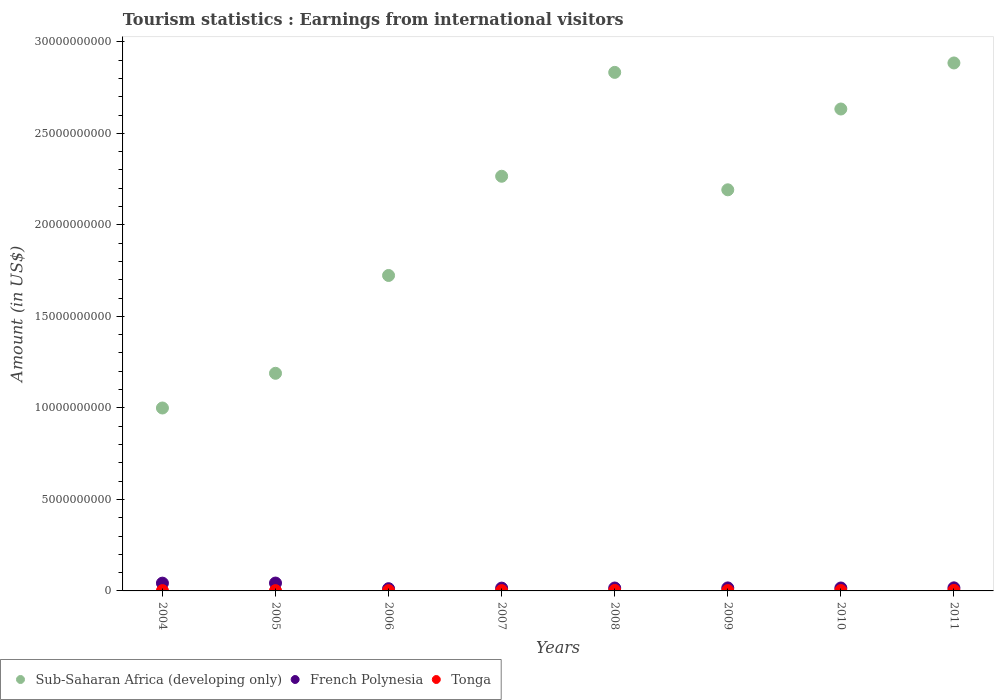How many different coloured dotlines are there?
Your answer should be compact. 3. Is the number of dotlines equal to the number of legend labels?
Give a very brief answer. Yes. What is the earnings from international visitors in Sub-Saharan Africa (developing only) in 2005?
Provide a succinct answer. 1.19e+1. Across all years, what is the maximum earnings from international visitors in Sub-Saharan Africa (developing only)?
Provide a succinct answer. 2.88e+1. Across all years, what is the minimum earnings from international visitors in French Polynesia?
Keep it short and to the point. 1.22e+08. What is the total earnings from international visitors in French Polynesia in the graph?
Your answer should be very brief. 1.78e+09. What is the difference between the earnings from international visitors in Tonga in 2005 and that in 2011?
Your answer should be compact. -1.18e+07. What is the difference between the earnings from international visitors in French Polynesia in 2004 and the earnings from international visitors in Tonga in 2010?
Your answer should be very brief. 4.05e+08. What is the average earnings from international visitors in French Polynesia per year?
Offer a terse response. 2.23e+08. In the year 2006, what is the difference between the earnings from international visitors in Sub-Saharan Africa (developing only) and earnings from international visitors in Tonga?
Your answer should be compact. 1.72e+1. In how many years, is the earnings from international visitors in French Polynesia greater than 25000000000 US$?
Ensure brevity in your answer.  0. What is the ratio of the earnings from international visitors in French Polynesia in 2006 to that in 2008?
Offer a terse response. 0.77. Is the earnings from international visitors in French Polynesia in 2008 less than that in 2009?
Your answer should be very brief. Yes. What is the difference between the highest and the second highest earnings from international visitors in Sub-Saharan Africa (developing only)?
Ensure brevity in your answer.  5.15e+08. What is the difference between the highest and the lowest earnings from international visitors in French Polynesia?
Your response must be concise. 3.08e+08. Is the sum of the earnings from international visitors in Tonga in 2007 and 2009 greater than the maximum earnings from international visitors in French Polynesia across all years?
Your answer should be very brief. No. Does the earnings from international visitors in Tonga monotonically increase over the years?
Provide a succinct answer. No. Is the earnings from international visitors in French Polynesia strictly less than the earnings from international visitors in Sub-Saharan Africa (developing only) over the years?
Give a very brief answer. Yes. How many dotlines are there?
Make the answer very short. 3. How many years are there in the graph?
Give a very brief answer. 8. Are the values on the major ticks of Y-axis written in scientific E-notation?
Offer a very short reply. No. Does the graph contain any zero values?
Your answer should be compact. No. Where does the legend appear in the graph?
Keep it short and to the point. Bottom left. How are the legend labels stacked?
Ensure brevity in your answer.  Horizontal. What is the title of the graph?
Keep it short and to the point. Tourism statistics : Earnings from international visitors. Does "Syrian Arab Republic" appear as one of the legend labels in the graph?
Offer a very short reply. No. What is the label or title of the X-axis?
Your answer should be very brief. Years. What is the label or title of the Y-axis?
Ensure brevity in your answer.  Amount (in US$). What is the Amount (in US$) of Sub-Saharan Africa (developing only) in 2004?
Give a very brief answer. 9.99e+09. What is the Amount (in US$) in French Polynesia in 2004?
Offer a very short reply. 4.25e+08. What is the Amount (in US$) in Tonga in 2004?
Give a very brief answer. 1.62e+07. What is the Amount (in US$) in Sub-Saharan Africa (developing only) in 2005?
Provide a succinct answer. 1.19e+1. What is the Amount (in US$) of French Polynesia in 2005?
Provide a short and direct response. 4.30e+08. What is the Amount (in US$) of Tonga in 2005?
Your answer should be compact. 1.60e+07. What is the Amount (in US$) in Sub-Saharan Africa (developing only) in 2006?
Provide a succinct answer. 1.72e+1. What is the Amount (in US$) of French Polynesia in 2006?
Provide a succinct answer. 1.22e+08. What is the Amount (in US$) of Tonga in 2006?
Make the answer very short. 1.50e+07. What is the Amount (in US$) of Sub-Saharan Africa (developing only) in 2007?
Your answer should be very brief. 2.27e+1. What is the Amount (in US$) in French Polynesia in 2007?
Your response must be concise. 1.53e+08. What is the Amount (in US$) in Tonga in 2007?
Your response must be concise. 1.73e+07. What is the Amount (in US$) of Sub-Saharan Africa (developing only) in 2008?
Make the answer very short. 2.83e+1. What is the Amount (in US$) of French Polynesia in 2008?
Ensure brevity in your answer.  1.59e+08. What is the Amount (in US$) in Tonga in 2008?
Your answer should be very brief. 2.51e+07. What is the Amount (in US$) of Sub-Saharan Africa (developing only) in 2009?
Your response must be concise. 2.19e+1. What is the Amount (in US$) in French Polynesia in 2009?
Provide a succinct answer. 1.64e+08. What is the Amount (in US$) of Tonga in 2009?
Your answer should be compact. 1.91e+07. What is the Amount (in US$) in Sub-Saharan Africa (developing only) in 2010?
Keep it short and to the point. 2.63e+1. What is the Amount (in US$) in French Polynesia in 2010?
Offer a very short reply. 1.60e+08. What is the Amount (in US$) of Tonga in 2010?
Keep it short and to the point. 2.04e+07. What is the Amount (in US$) in Sub-Saharan Africa (developing only) in 2011?
Offer a very short reply. 2.88e+1. What is the Amount (in US$) in French Polynesia in 2011?
Keep it short and to the point. 1.68e+08. What is the Amount (in US$) of Tonga in 2011?
Give a very brief answer. 2.78e+07. Across all years, what is the maximum Amount (in US$) in Sub-Saharan Africa (developing only)?
Your answer should be compact. 2.88e+1. Across all years, what is the maximum Amount (in US$) in French Polynesia?
Provide a short and direct response. 4.30e+08. Across all years, what is the maximum Amount (in US$) in Tonga?
Provide a succinct answer. 2.78e+07. Across all years, what is the minimum Amount (in US$) in Sub-Saharan Africa (developing only)?
Your response must be concise. 9.99e+09. Across all years, what is the minimum Amount (in US$) of French Polynesia?
Give a very brief answer. 1.22e+08. Across all years, what is the minimum Amount (in US$) in Tonga?
Your answer should be compact. 1.50e+07. What is the total Amount (in US$) of Sub-Saharan Africa (developing only) in the graph?
Offer a terse response. 1.67e+11. What is the total Amount (in US$) in French Polynesia in the graph?
Your answer should be very brief. 1.78e+09. What is the total Amount (in US$) of Tonga in the graph?
Your answer should be compact. 1.57e+08. What is the difference between the Amount (in US$) of Sub-Saharan Africa (developing only) in 2004 and that in 2005?
Keep it short and to the point. -1.90e+09. What is the difference between the Amount (in US$) in French Polynesia in 2004 and that in 2005?
Your response must be concise. -5.00e+06. What is the difference between the Amount (in US$) of Tonga in 2004 and that in 2005?
Make the answer very short. 2.00e+05. What is the difference between the Amount (in US$) of Sub-Saharan Africa (developing only) in 2004 and that in 2006?
Offer a terse response. -7.24e+09. What is the difference between the Amount (in US$) in French Polynesia in 2004 and that in 2006?
Make the answer very short. 3.03e+08. What is the difference between the Amount (in US$) of Tonga in 2004 and that in 2006?
Ensure brevity in your answer.  1.20e+06. What is the difference between the Amount (in US$) of Sub-Saharan Africa (developing only) in 2004 and that in 2007?
Provide a succinct answer. -1.27e+1. What is the difference between the Amount (in US$) in French Polynesia in 2004 and that in 2007?
Offer a very short reply. 2.72e+08. What is the difference between the Amount (in US$) of Tonga in 2004 and that in 2007?
Your answer should be very brief. -1.10e+06. What is the difference between the Amount (in US$) in Sub-Saharan Africa (developing only) in 2004 and that in 2008?
Ensure brevity in your answer.  -1.83e+1. What is the difference between the Amount (in US$) of French Polynesia in 2004 and that in 2008?
Ensure brevity in your answer.  2.66e+08. What is the difference between the Amount (in US$) of Tonga in 2004 and that in 2008?
Offer a very short reply. -8.90e+06. What is the difference between the Amount (in US$) in Sub-Saharan Africa (developing only) in 2004 and that in 2009?
Keep it short and to the point. -1.19e+1. What is the difference between the Amount (in US$) in French Polynesia in 2004 and that in 2009?
Provide a succinct answer. 2.61e+08. What is the difference between the Amount (in US$) of Tonga in 2004 and that in 2009?
Offer a very short reply. -2.90e+06. What is the difference between the Amount (in US$) of Sub-Saharan Africa (developing only) in 2004 and that in 2010?
Your response must be concise. -1.63e+1. What is the difference between the Amount (in US$) of French Polynesia in 2004 and that in 2010?
Offer a terse response. 2.65e+08. What is the difference between the Amount (in US$) of Tonga in 2004 and that in 2010?
Your answer should be compact. -4.20e+06. What is the difference between the Amount (in US$) in Sub-Saharan Africa (developing only) in 2004 and that in 2011?
Ensure brevity in your answer.  -1.89e+1. What is the difference between the Amount (in US$) of French Polynesia in 2004 and that in 2011?
Provide a succinct answer. 2.57e+08. What is the difference between the Amount (in US$) in Tonga in 2004 and that in 2011?
Keep it short and to the point. -1.16e+07. What is the difference between the Amount (in US$) in Sub-Saharan Africa (developing only) in 2005 and that in 2006?
Your response must be concise. -5.34e+09. What is the difference between the Amount (in US$) in French Polynesia in 2005 and that in 2006?
Offer a very short reply. 3.08e+08. What is the difference between the Amount (in US$) of Sub-Saharan Africa (developing only) in 2005 and that in 2007?
Give a very brief answer. -1.08e+1. What is the difference between the Amount (in US$) of French Polynesia in 2005 and that in 2007?
Provide a succinct answer. 2.77e+08. What is the difference between the Amount (in US$) in Tonga in 2005 and that in 2007?
Keep it short and to the point. -1.30e+06. What is the difference between the Amount (in US$) in Sub-Saharan Africa (developing only) in 2005 and that in 2008?
Offer a very short reply. -1.64e+1. What is the difference between the Amount (in US$) in French Polynesia in 2005 and that in 2008?
Make the answer very short. 2.71e+08. What is the difference between the Amount (in US$) in Tonga in 2005 and that in 2008?
Provide a succinct answer. -9.10e+06. What is the difference between the Amount (in US$) in Sub-Saharan Africa (developing only) in 2005 and that in 2009?
Provide a succinct answer. -1.00e+1. What is the difference between the Amount (in US$) of French Polynesia in 2005 and that in 2009?
Ensure brevity in your answer.  2.66e+08. What is the difference between the Amount (in US$) of Tonga in 2005 and that in 2009?
Your answer should be very brief. -3.10e+06. What is the difference between the Amount (in US$) of Sub-Saharan Africa (developing only) in 2005 and that in 2010?
Make the answer very short. -1.44e+1. What is the difference between the Amount (in US$) in French Polynesia in 2005 and that in 2010?
Offer a terse response. 2.70e+08. What is the difference between the Amount (in US$) in Tonga in 2005 and that in 2010?
Your answer should be very brief. -4.40e+06. What is the difference between the Amount (in US$) of Sub-Saharan Africa (developing only) in 2005 and that in 2011?
Make the answer very short. -1.70e+1. What is the difference between the Amount (in US$) of French Polynesia in 2005 and that in 2011?
Ensure brevity in your answer.  2.62e+08. What is the difference between the Amount (in US$) in Tonga in 2005 and that in 2011?
Your response must be concise. -1.18e+07. What is the difference between the Amount (in US$) in Sub-Saharan Africa (developing only) in 2006 and that in 2007?
Make the answer very short. -5.42e+09. What is the difference between the Amount (in US$) in French Polynesia in 2006 and that in 2007?
Give a very brief answer. -3.10e+07. What is the difference between the Amount (in US$) of Tonga in 2006 and that in 2007?
Ensure brevity in your answer.  -2.30e+06. What is the difference between the Amount (in US$) in Sub-Saharan Africa (developing only) in 2006 and that in 2008?
Provide a short and direct response. -1.11e+1. What is the difference between the Amount (in US$) of French Polynesia in 2006 and that in 2008?
Keep it short and to the point. -3.70e+07. What is the difference between the Amount (in US$) of Tonga in 2006 and that in 2008?
Provide a succinct answer. -1.01e+07. What is the difference between the Amount (in US$) in Sub-Saharan Africa (developing only) in 2006 and that in 2009?
Your answer should be very brief. -4.68e+09. What is the difference between the Amount (in US$) of French Polynesia in 2006 and that in 2009?
Your answer should be compact. -4.20e+07. What is the difference between the Amount (in US$) of Tonga in 2006 and that in 2009?
Offer a very short reply. -4.10e+06. What is the difference between the Amount (in US$) in Sub-Saharan Africa (developing only) in 2006 and that in 2010?
Offer a very short reply. -9.10e+09. What is the difference between the Amount (in US$) in French Polynesia in 2006 and that in 2010?
Provide a succinct answer. -3.80e+07. What is the difference between the Amount (in US$) of Tonga in 2006 and that in 2010?
Your response must be concise. -5.40e+06. What is the difference between the Amount (in US$) in Sub-Saharan Africa (developing only) in 2006 and that in 2011?
Your answer should be very brief. -1.16e+1. What is the difference between the Amount (in US$) in French Polynesia in 2006 and that in 2011?
Your response must be concise. -4.60e+07. What is the difference between the Amount (in US$) of Tonga in 2006 and that in 2011?
Your response must be concise. -1.28e+07. What is the difference between the Amount (in US$) in Sub-Saharan Africa (developing only) in 2007 and that in 2008?
Make the answer very short. -5.68e+09. What is the difference between the Amount (in US$) in French Polynesia in 2007 and that in 2008?
Provide a succinct answer. -6.00e+06. What is the difference between the Amount (in US$) of Tonga in 2007 and that in 2008?
Your answer should be very brief. -7.80e+06. What is the difference between the Amount (in US$) in Sub-Saharan Africa (developing only) in 2007 and that in 2009?
Provide a short and direct response. 7.40e+08. What is the difference between the Amount (in US$) in French Polynesia in 2007 and that in 2009?
Your response must be concise. -1.10e+07. What is the difference between the Amount (in US$) in Tonga in 2007 and that in 2009?
Provide a succinct answer. -1.80e+06. What is the difference between the Amount (in US$) of Sub-Saharan Africa (developing only) in 2007 and that in 2010?
Provide a short and direct response. -3.67e+09. What is the difference between the Amount (in US$) of French Polynesia in 2007 and that in 2010?
Your answer should be very brief. -7.00e+06. What is the difference between the Amount (in US$) in Tonga in 2007 and that in 2010?
Make the answer very short. -3.10e+06. What is the difference between the Amount (in US$) of Sub-Saharan Africa (developing only) in 2007 and that in 2011?
Your response must be concise. -6.19e+09. What is the difference between the Amount (in US$) in French Polynesia in 2007 and that in 2011?
Give a very brief answer. -1.50e+07. What is the difference between the Amount (in US$) in Tonga in 2007 and that in 2011?
Offer a terse response. -1.05e+07. What is the difference between the Amount (in US$) of Sub-Saharan Africa (developing only) in 2008 and that in 2009?
Offer a terse response. 6.42e+09. What is the difference between the Amount (in US$) in French Polynesia in 2008 and that in 2009?
Your answer should be very brief. -5.00e+06. What is the difference between the Amount (in US$) in Tonga in 2008 and that in 2009?
Keep it short and to the point. 6.00e+06. What is the difference between the Amount (in US$) in Sub-Saharan Africa (developing only) in 2008 and that in 2010?
Keep it short and to the point. 2.00e+09. What is the difference between the Amount (in US$) of Tonga in 2008 and that in 2010?
Your response must be concise. 4.70e+06. What is the difference between the Amount (in US$) in Sub-Saharan Africa (developing only) in 2008 and that in 2011?
Make the answer very short. -5.15e+08. What is the difference between the Amount (in US$) of French Polynesia in 2008 and that in 2011?
Your answer should be compact. -9.00e+06. What is the difference between the Amount (in US$) of Tonga in 2008 and that in 2011?
Give a very brief answer. -2.70e+06. What is the difference between the Amount (in US$) of Sub-Saharan Africa (developing only) in 2009 and that in 2010?
Offer a terse response. -4.41e+09. What is the difference between the Amount (in US$) in French Polynesia in 2009 and that in 2010?
Provide a succinct answer. 4.00e+06. What is the difference between the Amount (in US$) of Tonga in 2009 and that in 2010?
Give a very brief answer. -1.30e+06. What is the difference between the Amount (in US$) of Sub-Saharan Africa (developing only) in 2009 and that in 2011?
Ensure brevity in your answer.  -6.93e+09. What is the difference between the Amount (in US$) of Tonga in 2009 and that in 2011?
Ensure brevity in your answer.  -8.70e+06. What is the difference between the Amount (in US$) of Sub-Saharan Africa (developing only) in 2010 and that in 2011?
Your answer should be very brief. -2.52e+09. What is the difference between the Amount (in US$) of French Polynesia in 2010 and that in 2011?
Ensure brevity in your answer.  -8.00e+06. What is the difference between the Amount (in US$) of Tonga in 2010 and that in 2011?
Make the answer very short. -7.40e+06. What is the difference between the Amount (in US$) of Sub-Saharan Africa (developing only) in 2004 and the Amount (in US$) of French Polynesia in 2005?
Make the answer very short. 9.56e+09. What is the difference between the Amount (in US$) in Sub-Saharan Africa (developing only) in 2004 and the Amount (in US$) in Tonga in 2005?
Make the answer very short. 9.98e+09. What is the difference between the Amount (in US$) of French Polynesia in 2004 and the Amount (in US$) of Tonga in 2005?
Your response must be concise. 4.09e+08. What is the difference between the Amount (in US$) of Sub-Saharan Africa (developing only) in 2004 and the Amount (in US$) of French Polynesia in 2006?
Provide a succinct answer. 9.87e+09. What is the difference between the Amount (in US$) in Sub-Saharan Africa (developing only) in 2004 and the Amount (in US$) in Tonga in 2006?
Give a very brief answer. 9.98e+09. What is the difference between the Amount (in US$) in French Polynesia in 2004 and the Amount (in US$) in Tonga in 2006?
Make the answer very short. 4.10e+08. What is the difference between the Amount (in US$) in Sub-Saharan Africa (developing only) in 2004 and the Amount (in US$) in French Polynesia in 2007?
Keep it short and to the point. 9.84e+09. What is the difference between the Amount (in US$) of Sub-Saharan Africa (developing only) in 2004 and the Amount (in US$) of Tonga in 2007?
Keep it short and to the point. 9.98e+09. What is the difference between the Amount (in US$) of French Polynesia in 2004 and the Amount (in US$) of Tonga in 2007?
Your answer should be compact. 4.08e+08. What is the difference between the Amount (in US$) in Sub-Saharan Africa (developing only) in 2004 and the Amount (in US$) in French Polynesia in 2008?
Give a very brief answer. 9.84e+09. What is the difference between the Amount (in US$) of Sub-Saharan Africa (developing only) in 2004 and the Amount (in US$) of Tonga in 2008?
Your answer should be very brief. 9.97e+09. What is the difference between the Amount (in US$) in French Polynesia in 2004 and the Amount (in US$) in Tonga in 2008?
Your answer should be compact. 4.00e+08. What is the difference between the Amount (in US$) of Sub-Saharan Africa (developing only) in 2004 and the Amount (in US$) of French Polynesia in 2009?
Provide a succinct answer. 9.83e+09. What is the difference between the Amount (in US$) of Sub-Saharan Africa (developing only) in 2004 and the Amount (in US$) of Tonga in 2009?
Your answer should be very brief. 9.98e+09. What is the difference between the Amount (in US$) in French Polynesia in 2004 and the Amount (in US$) in Tonga in 2009?
Ensure brevity in your answer.  4.06e+08. What is the difference between the Amount (in US$) in Sub-Saharan Africa (developing only) in 2004 and the Amount (in US$) in French Polynesia in 2010?
Your answer should be very brief. 9.83e+09. What is the difference between the Amount (in US$) of Sub-Saharan Africa (developing only) in 2004 and the Amount (in US$) of Tonga in 2010?
Offer a very short reply. 9.97e+09. What is the difference between the Amount (in US$) of French Polynesia in 2004 and the Amount (in US$) of Tonga in 2010?
Your answer should be very brief. 4.05e+08. What is the difference between the Amount (in US$) in Sub-Saharan Africa (developing only) in 2004 and the Amount (in US$) in French Polynesia in 2011?
Offer a very short reply. 9.83e+09. What is the difference between the Amount (in US$) in Sub-Saharan Africa (developing only) in 2004 and the Amount (in US$) in Tonga in 2011?
Give a very brief answer. 9.97e+09. What is the difference between the Amount (in US$) in French Polynesia in 2004 and the Amount (in US$) in Tonga in 2011?
Make the answer very short. 3.97e+08. What is the difference between the Amount (in US$) in Sub-Saharan Africa (developing only) in 2005 and the Amount (in US$) in French Polynesia in 2006?
Ensure brevity in your answer.  1.18e+1. What is the difference between the Amount (in US$) in Sub-Saharan Africa (developing only) in 2005 and the Amount (in US$) in Tonga in 2006?
Make the answer very short. 1.19e+1. What is the difference between the Amount (in US$) in French Polynesia in 2005 and the Amount (in US$) in Tonga in 2006?
Your answer should be very brief. 4.15e+08. What is the difference between the Amount (in US$) of Sub-Saharan Africa (developing only) in 2005 and the Amount (in US$) of French Polynesia in 2007?
Offer a terse response. 1.17e+1. What is the difference between the Amount (in US$) in Sub-Saharan Africa (developing only) in 2005 and the Amount (in US$) in Tonga in 2007?
Keep it short and to the point. 1.19e+1. What is the difference between the Amount (in US$) of French Polynesia in 2005 and the Amount (in US$) of Tonga in 2007?
Your answer should be compact. 4.13e+08. What is the difference between the Amount (in US$) of Sub-Saharan Africa (developing only) in 2005 and the Amount (in US$) of French Polynesia in 2008?
Offer a very short reply. 1.17e+1. What is the difference between the Amount (in US$) of Sub-Saharan Africa (developing only) in 2005 and the Amount (in US$) of Tonga in 2008?
Give a very brief answer. 1.19e+1. What is the difference between the Amount (in US$) of French Polynesia in 2005 and the Amount (in US$) of Tonga in 2008?
Your answer should be very brief. 4.05e+08. What is the difference between the Amount (in US$) of Sub-Saharan Africa (developing only) in 2005 and the Amount (in US$) of French Polynesia in 2009?
Keep it short and to the point. 1.17e+1. What is the difference between the Amount (in US$) in Sub-Saharan Africa (developing only) in 2005 and the Amount (in US$) in Tonga in 2009?
Your response must be concise. 1.19e+1. What is the difference between the Amount (in US$) of French Polynesia in 2005 and the Amount (in US$) of Tonga in 2009?
Keep it short and to the point. 4.11e+08. What is the difference between the Amount (in US$) of Sub-Saharan Africa (developing only) in 2005 and the Amount (in US$) of French Polynesia in 2010?
Make the answer very short. 1.17e+1. What is the difference between the Amount (in US$) of Sub-Saharan Africa (developing only) in 2005 and the Amount (in US$) of Tonga in 2010?
Offer a very short reply. 1.19e+1. What is the difference between the Amount (in US$) in French Polynesia in 2005 and the Amount (in US$) in Tonga in 2010?
Offer a very short reply. 4.10e+08. What is the difference between the Amount (in US$) of Sub-Saharan Africa (developing only) in 2005 and the Amount (in US$) of French Polynesia in 2011?
Your answer should be very brief. 1.17e+1. What is the difference between the Amount (in US$) in Sub-Saharan Africa (developing only) in 2005 and the Amount (in US$) in Tonga in 2011?
Ensure brevity in your answer.  1.19e+1. What is the difference between the Amount (in US$) in French Polynesia in 2005 and the Amount (in US$) in Tonga in 2011?
Offer a very short reply. 4.02e+08. What is the difference between the Amount (in US$) of Sub-Saharan Africa (developing only) in 2006 and the Amount (in US$) of French Polynesia in 2007?
Offer a very short reply. 1.71e+1. What is the difference between the Amount (in US$) of Sub-Saharan Africa (developing only) in 2006 and the Amount (in US$) of Tonga in 2007?
Offer a terse response. 1.72e+1. What is the difference between the Amount (in US$) in French Polynesia in 2006 and the Amount (in US$) in Tonga in 2007?
Make the answer very short. 1.05e+08. What is the difference between the Amount (in US$) in Sub-Saharan Africa (developing only) in 2006 and the Amount (in US$) in French Polynesia in 2008?
Give a very brief answer. 1.71e+1. What is the difference between the Amount (in US$) in Sub-Saharan Africa (developing only) in 2006 and the Amount (in US$) in Tonga in 2008?
Keep it short and to the point. 1.72e+1. What is the difference between the Amount (in US$) in French Polynesia in 2006 and the Amount (in US$) in Tonga in 2008?
Your response must be concise. 9.69e+07. What is the difference between the Amount (in US$) of Sub-Saharan Africa (developing only) in 2006 and the Amount (in US$) of French Polynesia in 2009?
Provide a short and direct response. 1.71e+1. What is the difference between the Amount (in US$) in Sub-Saharan Africa (developing only) in 2006 and the Amount (in US$) in Tonga in 2009?
Give a very brief answer. 1.72e+1. What is the difference between the Amount (in US$) in French Polynesia in 2006 and the Amount (in US$) in Tonga in 2009?
Your answer should be compact. 1.03e+08. What is the difference between the Amount (in US$) of Sub-Saharan Africa (developing only) in 2006 and the Amount (in US$) of French Polynesia in 2010?
Ensure brevity in your answer.  1.71e+1. What is the difference between the Amount (in US$) in Sub-Saharan Africa (developing only) in 2006 and the Amount (in US$) in Tonga in 2010?
Your answer should be very brief. 1.72e+1. What is the difference between the Amount (in US$) in French Polynesia in 2006 and the Amount (in US$) in Tonga in 2010?
Provide a succinct answer. 1.02e+08. What is the difference between the Amount (in US$) of Sub-Saharan Africa (developing only) in 2006 and the Amount (in US$) of French Polynesia in 2011?
Provide a short and direct response. 1.71e+1. What is the difference between the Amount (in US$) in Sub-Saharan Africa (developing only) in 2006 and the Amount (in US$) in Tonga in 2011?
Give a very brief answer. 1.72e+1. What is the difference between the Amount (in US$) of French Polynesia in 2006 and the Amount (in US$) of Tonga in 2011?
Ensure brevity in your answer.  9.42e+07. What is the difference between the Amount (in US$) of Sub-Saharan Africa (developing only) in 2007 and the Amount (in US$) of French Polynesia in 2008?
Provide a short and direct response. 2.25e+1. What is the difference between the Amount (in US$) in Sub-Saharan Africa (developing only) in 2007 and the Amount (in US$) in Tonga in 2008?
Offer a terse response. 2.26e+1. What is the difference between the Amount (in US$) in French Polynesia in 2007 and the Amount (in US$) in Tonga in 2008?
Your response must be concise. 1.28e+08. What is the difference between the Amount (in US$) of Sub-Saharan Africa (developing only) in 2007 and the Amount (in US$) of French Polynesia in 2009?
Your answer should be compact. 2.25e+1. What is the difference between the Amount (in US$) of Sub-Saharan Africa (developing only) in 2007 and the Amount (in US$) of Tonga in 2009?
Provide a succinct answer. 2.26e+1. What is the difference between the Amount (in US$) of French Polynesia in 2007 and the Amount (in US$) of Tonga in 2009?
Your answer should be compact. 1.34e+08. What is the difference between the Amount (in US$) of Sub-Saharan Africa (developing only) in 2007 and the Amount (in US$) of French Polynesia in 2010?
Provide a succinct answer. 2.25e+1. What is the difference between the Amount (in US$) in Sub-Saharan Africa (developing only) in 2007 and the Amount (in US$) in Tonga in 2010?
Make the answer very short. 2.26e+1. What is the difference between the Amount (in US$) in French Polynesia in 2007 and the Amount (in US$) in Tonga in 2010?
Give a very brief answer. 1.33e+08. What is the difference between the Amount (in US$) in Sub-Saharan Africa (developing only) in 2007 and the Amount (in US$) in French Polynesia in 2011?
Your answer should be very brief. 2.25e+1. What is the difference between the Amount (in US$) in Sub-Saharan Africa (developing only) in 2007 and the Amount (in US$) in Tonga in 2011?
Offer a terse response. 2.26e+1. What is the difference between the Amount (in US$) in French Polynesia in 2007 and the Amount (in US$) in Tonga in 2011?
Ensure brevity in your answer.  1.25e+08. What is the difference between the Amount (in US$) of Sub-Saharan Africa (developing only) in 2008 and the Amount (in US$) of French Polynesia in 2009?
Provide a short and direct response. 2.82e+1. What is the difference between the Amount (in US$) of Sub-Saharan Africa (developing only) in 2008 and the Amount (in US$) of Tonga in 2009?
Make the answer very short. 2.83e+1. What is the difference between the Amount (in US$) of French Polynesia in 2008 and the Amount (in US$) of Tonga in 2009?
Provide a succinct answer. 1.40e+08. What is the difference between the Amount (in US$) in Sub-Saharan Africa (developing only) in 2008 and the Amount (in US$) in French Polynesia in 2010?
Provide a succinct answer. 2.82e+1. What is the difference between the Amount (in US$) of Sub-Saharan Africa (developing only) in 2008 and the Amount (in US$) of Tonga in 2010?
Offer a terse response. 2.83e+1. What is the difference between the Amount (in US$) in French Polynesia in 2008 and the Amount (in US$) in Tonga in 2010?
Make the answer very short. 1.39e+08. What is the difference between the Amount (in US$) of Sub-Saharan Africa (developing only) in 2008 and the Amount (in US$) of French Polynesia in 2011?
Provide a succinct answer. 2.82e+1. What is the difference between the Amount (in US$) in Sub-Saharan Africa (developing only) in 2008 and the Amount (in US$) in Tonga in 2011?
Your answer should be compact. 2.83e+1. What is the difference between the Amount (in US$) in French Polynesia in 2008 and the Amount (in US$) in Tonga in 2011?
Your answer should be compact. 1.31e+08. What is the difference between the Amount (in US$) of Sub-Saharan Africa (developing only) in 2009 and the Amount (in US$) of French Polynesia in 2010?
Offer a very short reply. 2.18e+1. What is the difference between the Amount (in US$) in Sub-Saharan Africa (developing only) in 2009 and the Amount (in US$) in Tonga in 2010?
Ensure brevity in your answer.  2.19e+1. What is the difference between the Amount (in US$) in French Polynesia in 2009 and the Amount (in US$) in Tonga in 2010?
Offer a very short reply. 1.44e+08. What is the difference between the Amount (in US$) in Sub-Saharan Africa (developing only) in 2009 and the Amount (in US$) in French Polynesia in 2011?
Your answer should be very brief. 2.17e+1. What is the difference between the Amount (in US$) in Sub-Saharan Africa (developing only) in 2009 and the Amount (in US$) in Tonga in 2011?
Provide a short and direct response. 2.19e+1. What is the difference between the Amount (in US$) of French Polynesia in 2009 and the Amount (in US$) of Tonga in 2011?
Make the answer very short. 1.36e+08. What is the difference between the Amount (in US$) in Sub-Saharan Africa (developing only) in 2010 and the Amount (in US$) in French Polynesia in 2011?
Offer a terse response. 2.62e+1. What is the difference between the Amount (in US$) in Sub-Saharan Africa (developing only) in 2010 and the Amount (in US$) in Tonga in 2011?
Your answer should be compact. 2.63e+1. What is the difference between the Amount (in US$) in French Polynesia in 2010 and the Amount (in US$) in Tonga in 2011?
Keep it short and to the point. 1.32e+08. What is the average Amount (in US$) of Sub-Saharan Africa (developing only) per year?
Provide a succinct answer. 2.09e+1. What is the average Amount (in US$) in French Polynesia per year?
Offer a very short reply. 2.23e+08. What is the average Amount (in US$) in Tonga per year?
Offer a terse response. 1.96e+07. In the year 2004, what is the difference between the Amount (in US$) in Sub-Saharan Africa (developing only) and Amount (in US$) in French Polynesia?
Provide a short and direct response. 9.57e+09. In the year 2004, what is the difference between the Amount (in US$) in Sub-Saharan Africa (developing only) and Amount (in US$) in Tonga?
Offer a terse response. 9.98e+09. In the year 2004, what is the difference between the Amount (in US$) in French Polynesia and Amount (in US$) in Tonga?
Provide a short and direct response. 4.09e+08. In the year 2005, what is the difference between the Amount (in US$) of Sub-Saharan Africa (developing only) and Amount (in US$) of French Polynesia?
Ensure brevity in your answer.  1.15e+1. In the year 2005, what is the difference between the Amount (in US$) of Sub-Saharan Africa (developing only) and Amount (in US$) of Tonga?
Give a very brief answer. 1.19e+1. In the year 2005, what is the difference between the Amount (in US$) in French Polynesia and Amount (in US$) in Tonga?
Offer a very short reply. 4.14e+08. In the year 2006, what is the difference between the Amount (in US$) of Sub-Saharan Africa (developing only) and Amount (in US$) of French Polynesia?
Provide a short and direct response. 1.71e+1. In the year 2006, what is the difference between the Amount (in US$) of Sub-Saharan Africa (developing only) and Amount (in US$) of Tonga?
Give a very brief answer. 1.72e+1. In the year 2006, what is the difference between the Amount (in US$) in French Polynesia and Amount (in US$) in Tonga?
Give a very brief answer. 1.07e+08. In the year 2007, what is the difference between the Amount (in US$) of Sub-Saharan Africa (developing only) and Amount (in US$) of French Polynesia?
Ensure brevity in your answer.  2.25e+1. In the year 2007, what is the difference between the Amount (in US$) of Sub-Saharan Africa (developing only) and Amount (in US$) of Tonga?
Your response must be concise. 2.26e+1. In the year 2007, what is the difference between the Amount (in US$) in French Polynesia and Amount (in US$) in Tonga?
Give a very brief answer. 1.36e+08. In the year 2008, what is the difference between the Amount (in US$) of Sub-Saharan Africa (developing only) and Amount (in US$) of French Polynesia?
Your response must be concise. 2.82e+1. In the year 2008, what is the difference between the Amount (in US$) in Sub-Saharan Africa (developing only) and Amount (in US$) in Tonga?
Your answer should be compact. 2.83e+1. In the year 2008, what is the difference between the Amount (in US$) in French Polynesia and Amount (in US$) in Tonga?
Give a very brief answer. 1.34e+08. In the year 2009, what is the difference between the Amount (in US$) of Sub-Saharan Africa (developing only) and Amount (in US$) of French Polynesia?
Provide a short and direct response. 2.18e+1. In the year 2009, what is the difference between the Amount (in US$) in Sub-Saharan Africa (developing only) and Amount (in US$) in Tonga?
Your response must be concise. 2.19e+1. In the year 2009, what is the difference between the Amount (in US$) in French Polynesia and Amount (in US$) in Tonga?
Keep it short and to the point. 1.45e+08. In the year 2010, what is the difference between the Amount (in US$) of Sub-Saharan Africa (developing only) and Amount (in US$) of French Polynesia?
Your answer should be compact. 2.62e+1. In the year 2010, what is the difference between the Amount (in US$) of Sub-Saharan Africa (developing only) and Amount (in US$) of Tonga?
Offer a very short reply. 2.63e+1. In the year 2010, what is the difference between the Amount (in US$) of French Polynesia and Amount (in US$) of Tonga?
Give a very brief answer. 1.40e+08. In the year 2011, what is the difference between the Amount (in US$) of Sub-Saharan Africa (developing only) and Amount (in US$) of French Polynesia?
Offer a very short reply. 2.87e+1. In the year 2011, what is the difference between the Amount (in US$) of Sub-Saharan Africa (developing only) and Amount (in US$) of Tonga?
Provide a short and direct response. 2.88e+1. In the year 2011, what is the difference between the Amount (in US$) of French Polynesia and Amount (in US$) of Tonga?
Provide a succinct answer. 1.40e+08. What is the ratio of the Amount (in US$) in Sub-Saharan Africa (developing only) in 2004 to that in 2005?
Give a very brief answer. 0.84. What is the ratio of the Amount (in US$) in French Polynesia in 2004 to that in 2005?
Give a very brief answer. 0.99. What is the ratio of the Amount (in US$) in Tonga in 2004 to that in 2005?
Your response must be concise. 1.01. What is the ratio of the Amount (in US$) in Sub-Saharan Africa (developing only) in 2004 to that in 2006?
Give a very brief answer. 0.58. What is the ratio of the Amount (in US$) of French Polynesia in 2004 to that in 2006?
Keep it short and to the point. 3.48. What is the ratio of the Amount (in US$) of Sub-Saharan Africa (developing only) in 2004 to that in 2007?
Keep it short and to the point. 0.44. What is the ratio of the Amount (in US$) in French Polynesia in 2004 to that in 2007?
Keep it short and to the point. 2.78. What is the ratio of the Amount (in US$) in Tonga in 2004 to that in 2007?
Ensure brevity in your answer.  0.94. What is the ratio of the Amount (in US$) of Sub-Saharan Africa (developing only) in 2004 to that in 2008?
Provide a short and direct response. 0.35. What is the ratio of the Amount (in US$) of French Polynesia in 2004 to that in 2008?
Provide a succinct answer. 2.67. What is the ratio of the Amount (in US$) in Tonga in 2004 to that in 2008?
Offer a very short reply. 0.65. What is the ratio of the Amount (in US$) in Sub-Saharan Africa (developing only) in 2004 to that in 2009?
Offer a terse response. 0.46. What is the ratio of the Amount (in US$) in French Polynesia in 2004 to that in 2009?
Your answer should be compact. 2.59. What is the ratio of the Amount (in US$) of Tonga in 2004 to that in 2009?
Keep it short and to the point. 0.85. What is the ratio of the Amount (in US$) in Sub-Saharan Africa (developing only) in 2004 to that in 2010?
Keep it short and to the point. 0.38. What is the ratio of the Amount (in US$) in French Polynesia in 2004 to that in 2010?
Provide a short and direct response. 2.66. What is the ratio of the Amount (in US$) of Tonga in 2004 to that in 2010?
Make the answer very short. 0.79. What is the ratio of the Amount (in US$) in Sub-Saharan Africa (developing only) in 2004 to that in 2011?
Provide a short and direct response. 0.35. What is the ratio of the Amount (in US$) of French Polynesia in 2004 to that in 2011?
Give a very brief answer. 2.53. What is the ratio of the Amount (in US$) of Tonga in 2004 to that in 2011?
Ensure brevity in your answer.  0.58. What is the ratio of the Amount (in US$) in Sub-Saharan Africa (developing only) in 2005 to that in 2006?
Offer a very short reply. 0.69. What is the ratio of the Amount (in US$) in French Polynesia in 2005 to that in 2006?
Give a very brief answer. 3.52. What is the ratio of the Amount (in US$) of Tonga in 2005 to that in 2006?
Offer a terse response. 1.07. What is the ratio of the Amount (in US$) of Sub-Saharan Africa (developing only) in 2005 to that in 2007?
Your response must be concise. 0.52. What is the ratio of the Amount (in US$) in French Polynesia in 2005 to that in 2007?
Offer a terse response. 2.81. What is the ratio of the Amount (in US$) of Tonga in 2005 to that in 2007?
Offer a very short reply. 0.92. What is the ratio of the Amount (in US$) in Sub-Saharan Africa (developing only) in 2005 to that in 2008?
Give a very brief answer. 0.42. What is the ratio of the Amount (in US$) in French Polynesia in 2005 to that in 2008?
Offer a very short reply. 2.7. What is the ratio of the Amount (in US$) of Tonga in 2005 to that in 2008?
Offer a terse response. 0.64. What is the ratio of the Amount (in US$) of Sub-Saharan Africa (developing only) in 2005 to that in 2009?
Offer a terse response. 0.54. What is the ratio of the Amount (in US$) of French Polynesia in 2005 to that in 2009?
Give a very brief answer. 2.62. What is the ratio of the Amount (in US$) in Tonga in 2005 to that in 2009?
Give a very brief answer. 0.84. What is the ratio of the Amount (in US$) in Sub-Saharan Africa (developing only) in 2005 to that in 2010?
Your answer should be very brief. 0.45. What is the ratio of the Amount (in US$) in French Polynesia in 2005 to that in 2010?
Your response must be concise. 2.69. What is the ratio of the Amount (in US$) in Tonga in 2005 to that in 2010?
Offer a very short reply. 0.78. What is the ratio of the Amount (in US$) of Sub-Saharan Africa (developing only) in 2005 to that in 2011?
Your answer should be compact. 0.41. What is the ratio of the Amount (in US$) in French Polynesia in 2005 to that in 2011?
Your answer should be very brief. 2.56. What is the ratio of the Amount (in US$) of Tonga in 2005 to that in 2011?
Ensure brevity in your answer.  0.58. What is the ratio of the Amount (in US$) in Sub-Saharan Africa (developing only) in 2006 to that in 2007?
Offer a terse response. 0.76. What is the ratio of the Amount (in US$) of French Polynesia in 2006 to that in 2007?
Make the answer very short. 0.8. What is the ratio of the Amount (in US$) of Tonga in 2006 to that in 2007?
Offer a terse response. 0.87. What is the ratio of the Amount (in US$) of Sub-Saharan Africa (developing only) in 2006 to that in 2008?
Give a very brief answer. 0.61. What is the ratio of the Amount (in US$) in French Polynesia in 2006 to that in 2008?
Your answer should be very brief. 0.77. What is the ratio of the Amount (in US$) of Tonga in 2006 to that in 2008?
Ensure brevity in your answer.  0.6. What is the ratio of the Amount (in US$) of Sub-Saharan Africa (developing only) in 2006 to that in 2009?
Your answer should be compact. 0.79. What is the ratio of the Amount (in US$) of French Polynesia in 2006 to that in 2009?
Give a very brief answer. 0.74. What is the ratio of the Amount (in US$) of Tonga in 2006 to that in 2009?
Your answer should be very brief. 0.79. What is the ratio of the Amount (in US$) of Sub-Saharan Africa (developing only) in 2006 to that in 2010?
Provide a succinct answer. 0.65. What is the ratio of the Amount (in US$) in French Polynesia in 2006 to that in 2010?
Make the answer very short. 0.76. What is the ratio of the Amount (in US$) in Tonga in 2006 to that in 2010?
Your response must be concise. 0.74. What is the ratio of the Amount (in US$) in Sub-Saharan Africa (developing only) in 2006 to that in 2011?
Provide a short and direct response. 0.6. What is the ratio of the Amount (in US$) of French Polynesia in 2006 to that in 2011?
Offer a terse response. 0.73. What is the ratio of the Amount (in US$) in Tonga in 2006 to that in 2011?
Give a very brief answer. 0.54. What is the ratio of the Amount (in US$) in Sub-Saharan Africa (developing only) in 2007 to that in 2008?
Provide a short and direct response. 0.8. What is the ratio of the Amount (in US$) in French Polynesia in 2007 to that in 2008?
Your response must be concise. 0.96. What is the ratio of the Amount (in US$) of Tonga in 2007 to that in 2008?
Give a very brief answer. 0.69. What is the ratio of the Amount (in US$) in Sub-Saharan Africa (developing only) in 2007 to that in 2009?
Make the answer very short. 1.03. What is the ratio of the Amount (in US$) of French Polynesia in 2007 to that in 2009?
Your answer should be compact. 0.93. What is the ratio of the Amount (in US$) in Tonga in 2007 to that in 2009?
Your answer should be very brief. 0.91. What is the ratio of the Amount (in US$) of Sub-Saharan Africa (developing only) in 2007 to that in 2010?
Offer a terse response. 0.86. What is the ratio of the Amount (in US$) in French Polynesia in 2007 to that in 2010?
Offer a terse response. 0.96. What is the ratio of the Amount (in US$) of Tonga in 2007 to that in 2010?
Keep it short and to the point. 0.85. What is the ratio of the Amount (in US$) of Sub-Saharan Africa (developing only) in 2007 to that in 2011?
Offer a terse response. 0.79. What is the ratio of the Amount (in US$) in French Polynesia in 2007 to that in 2011?
Your response must be concise. 0.91. What is the ratio of the Amount (in US$) of Tonga in 2007 to that in 2011?
Provide a succinct answer. 0.62. What is the ratio of the Amount (in US$) of Sub-Saharan Africa (developing only) in 2008 to that in 2009?
Provide a short and direct response. 1.29. What is the ratio of the Amount (in US$) in French Polynesia in 2008 to that in 2009?
Your answer should be very brief. 0.97. What is the ratio of the Amount (in US$) in Tonga in 2008 to that in 2009?
Make the answer very short. 1.31. What is the ratio of the Amount (in US$) of Sub-Saharan Africa (developing only) in 2008 to that in 2010?
Provide a short and direct response. 1.08. What is the ratio of the Amount (in US$) in Tonga in 2008 to that in 2010?
Your response must be concise. 1.23. What is the ratio of the Amount (in US$) of Sub-Saharan Africa (developing only) in 2008 to that in 2011?
Your answer should be compact. 0.98. What is the ratio of the Amount (in US$) of French Polynesia in 2008 to that in 2011?
Offer a very short reply. 0.95. What is the ratio of the Amount (in US$) of Tonga in 2008 to that in 2011?
Offer a very short reply. 0.9. What is the ratio of the Amount (in US$) in Sub-Saharan Africa (developing only) in 2009 to that in 2010?
Your answer should be compact. 0.83. What is the ratio of the Amount (in US$) of French Polynesia in 2009 to that in 2010?
Provide a succinct answer. 1.02. What is the ratio of the Amount (in US$) in Tonga in 2009 to that in 2010?
Keep it short and to the point. 0.94. What is the ratio of the Amount (in US$) of Sub-Saharan Africa (developing only) in 2009 to that in 2011?
Offer a very short reply. 0.76. What is the ratio of the Amount (in US$) in French Polynesia in 2009 to that in 2011?
Your answer should be compact. 0.98. What is the ratio of the Amount (in US$) of Tonga in 2009 to that in 2011?
Give a very brief answer. 0.69. What is the ratio of the Amount (in US$) of Sub-Saharan Africa (developing only) in 2010 to that in 2011?
Your answer should be compact. 0.91. What is the ratio of the Amount (in US$) of French Polynesia in 2010 to that in 2011?
Give a very brief answer. 0.95. What is the ratio of the Amount (in US$) of Tonga in 2010 to that in 2011?
Keep it short and to the point. 0.73. What is the difference between the highest and the second highest Amount (in US$) in Sub-Saharan Africa (developing only)?
Give a very brief answer. 5.15e+08. What is the difference between the highest and the second highest Amount (in US$) in Tonga?
Provide a succinct answer. 2.70e+06. What is the difference between the highest and the lowest Amount (in US$) of Sub-Saharan Africa (developing only)?
Keep it short and to the point. 1.89e+1. What is the difference between the highest and the lowest Amount (in US$) in French Polynesia?
Give a very brief answer. 3.08e+08. What is the difference between the highest and the lowest Amount (in US$) of Tonga?
Make the answer very short. 1.28e+07. 